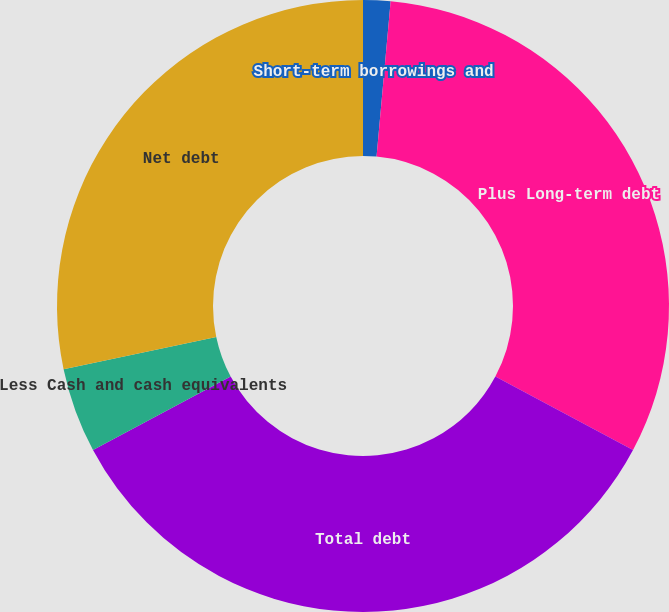Convert chart. <chart><loc_0><loc_0><loc_500><loc_500><pie_chart><fcel>Short-term borrowings and<fcel>Plus Long-term debt<fcel>Total debt<fcel>Less Cash and cash equivalents<fcel>Net debt<nl><fcel>1.44%<fcel>31.36%<fcel>34.41%<fcel>4.49%<fcel>28.31%<nl></chart> 